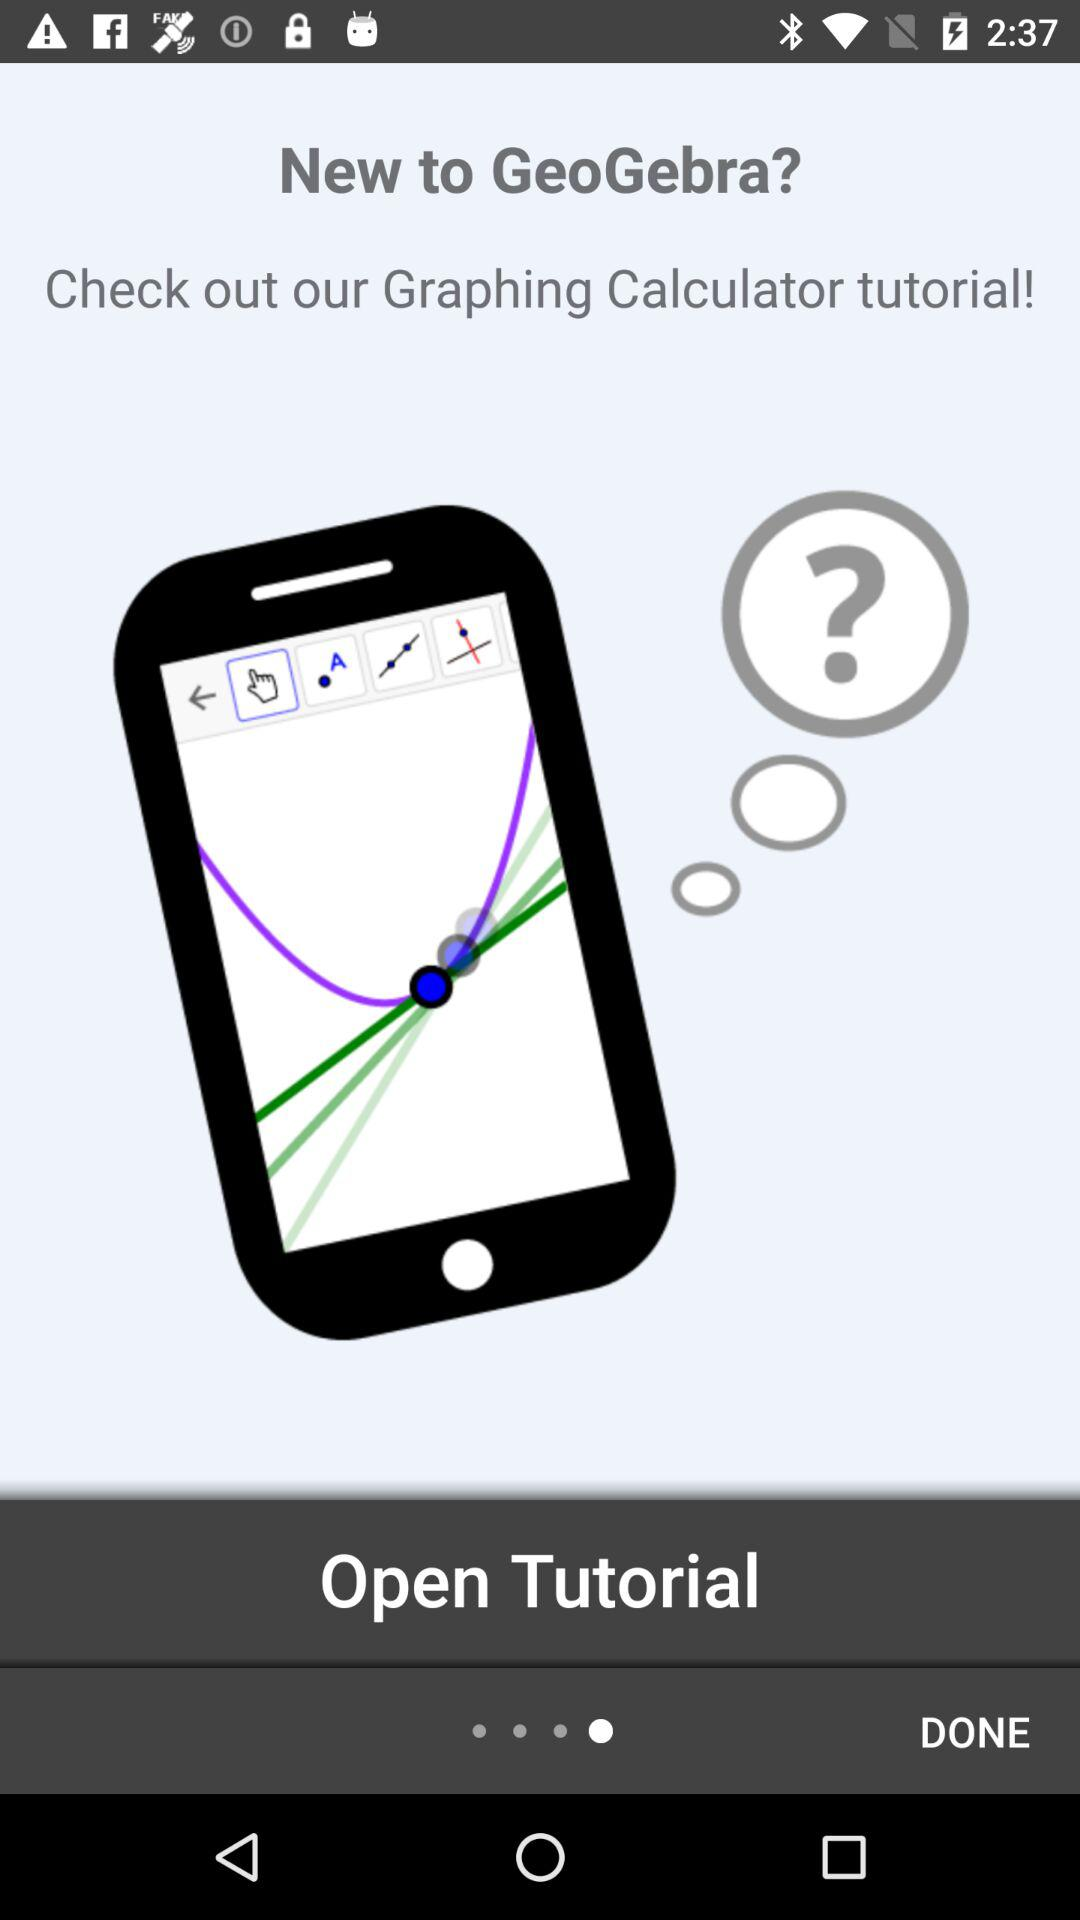What is the application name? The application name is "GeoGebra". 